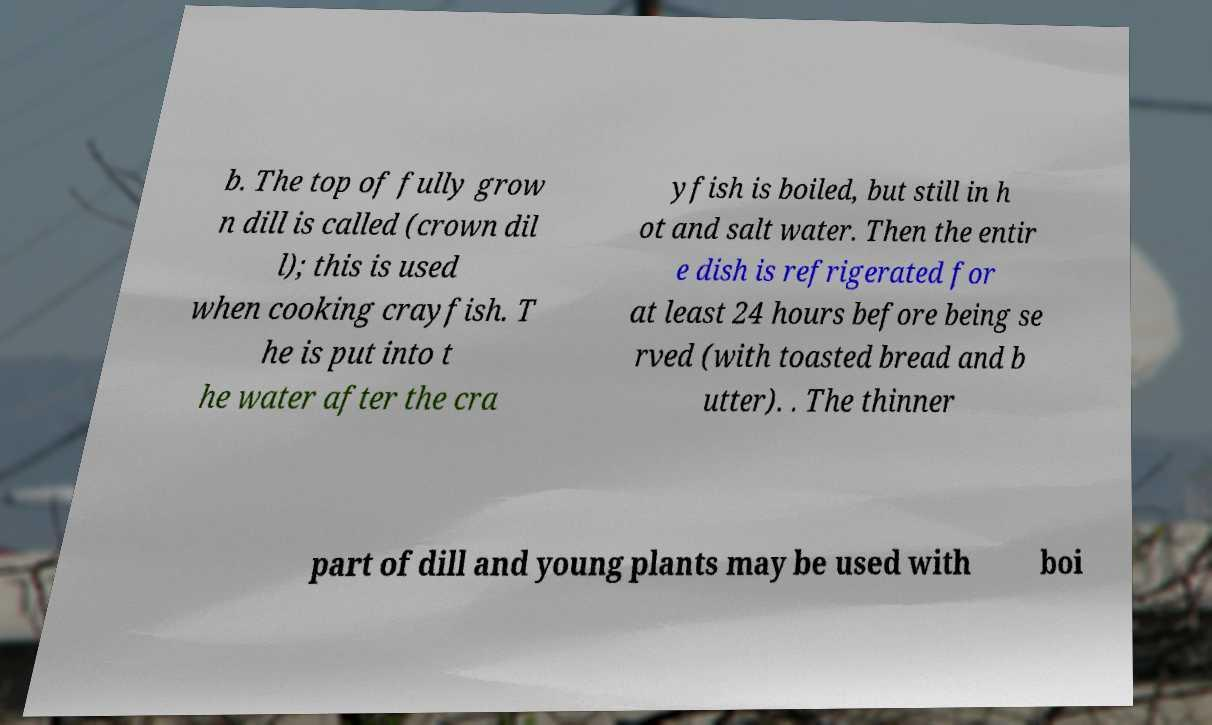For documentation purposes, I need the text within this image transcribed. Could you provide that? b. The top of fully grow n dill is called (crown dil l); this is used when cooking crayfish. T he is put into t he water after the cra yfish is boiled, but still in h ot and salt water. Then the entir e dish is refrigerated for at least 24 hours before being se rved (with toasted bread and b utter). . The thinner part of dill and young plants may be used with boi 